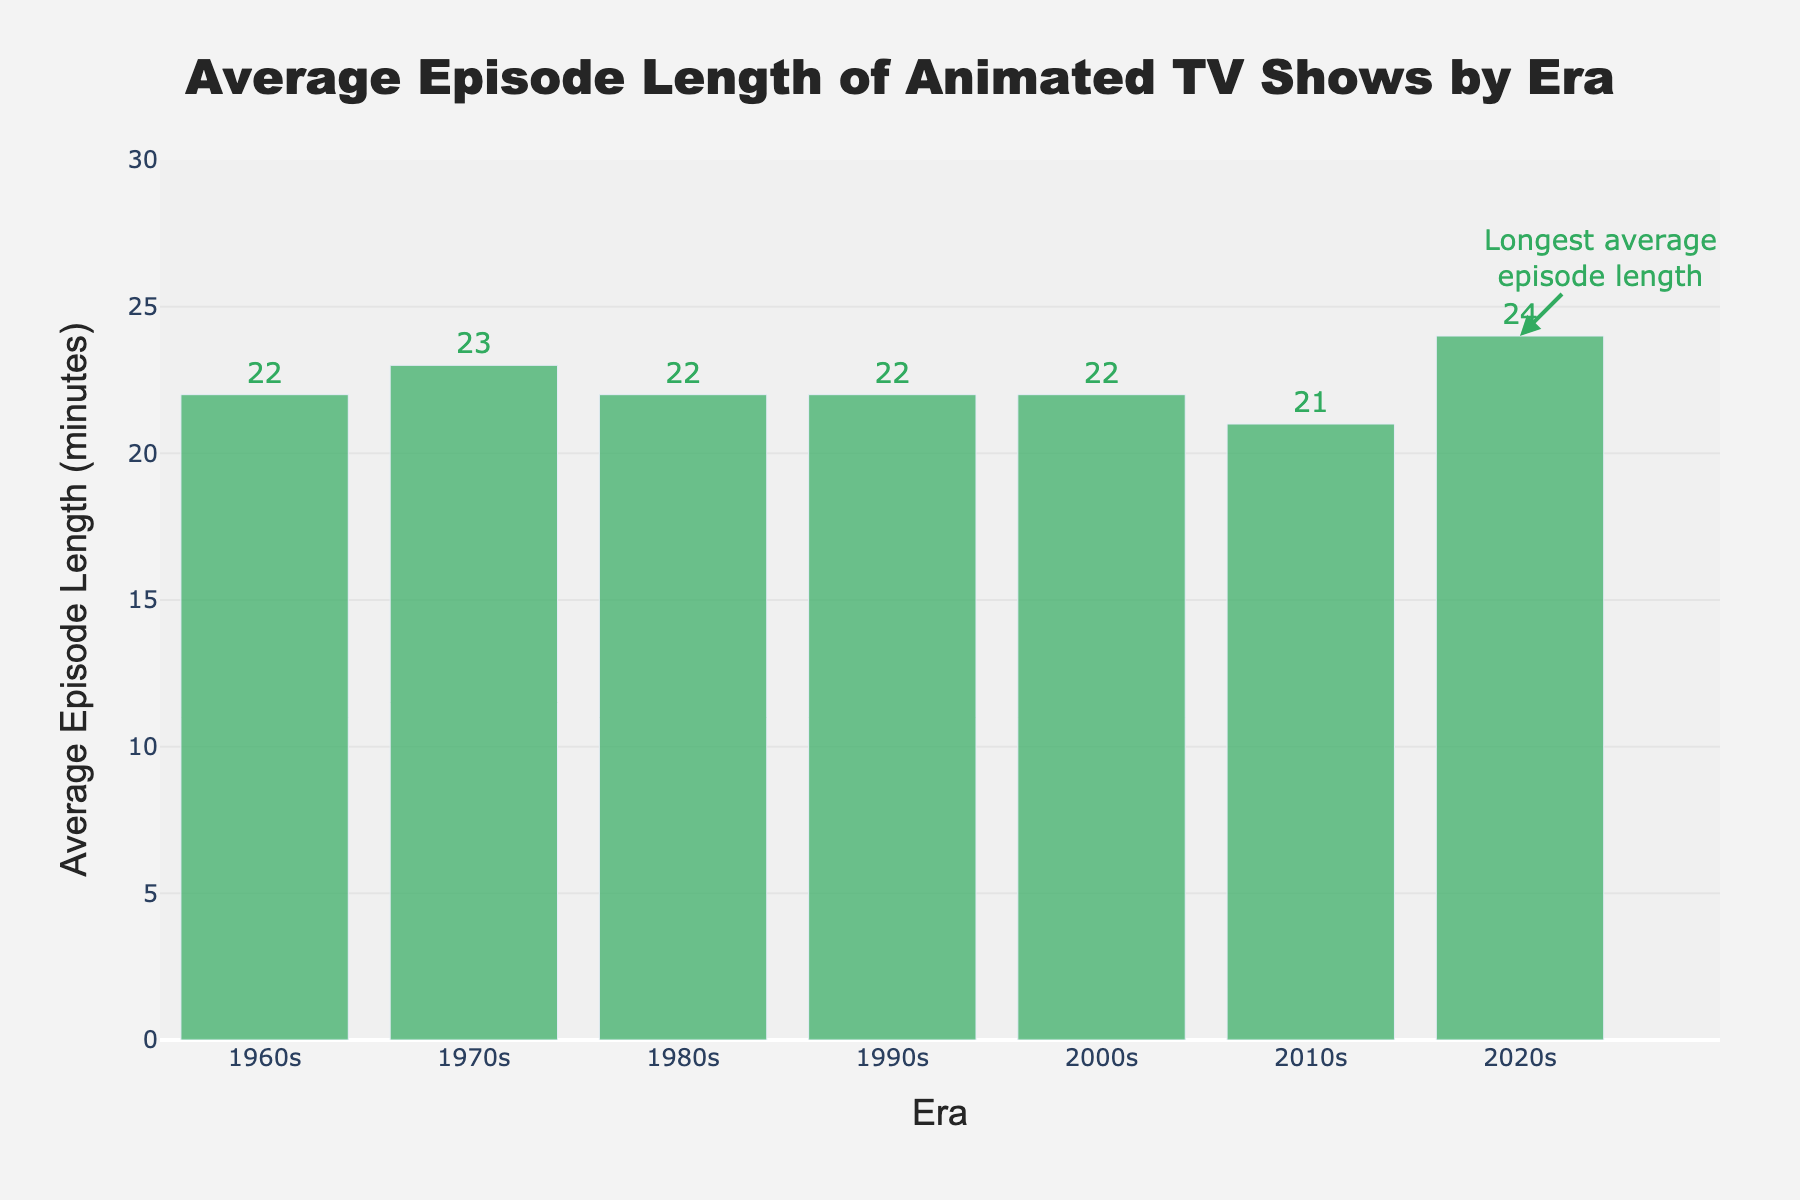What is the average episode length in the 2000s? The bar representing the 2000s shows an average episode length of 22 minutes.
Answer: 22 minutes Which era has the longest average episode length? The bar for the 2020s is the highest among all the bars, indicating the longest average episode length of 24 minutes.
Answer: 2020s By how much did the average episode length increase from the 2010s to the 2020s? The average episode length in the 2010s is 21 minutes, and in the 2020s it is 24 minutes. The difference is 24 - 21 = 3 minutes.
Answer: 3 minutes Compare the average episode lengths between the 1970s and the 2020s. Which one is longer and by how much? The 1970s have an average episode length of 23 minutes, while the 2020s have an average of 24 minutes. The 2020s are longer by 24 - 23 = 1 minute.
Answer: 2020s by 1 minute What is the trend in episode length from the 2010s to the 2020s? The average episode length has increased from 21 minutes in the 2010s to 24 minutes in the 2020s.
Answer: Increasing Is there any era where the average episode length is less than 22 minutes? Yes, the 2010s era has an average episode length of 21 minutes, which is less than 22 minutes.
Answer: 2010s What is the average episode length of animated TV shows in the 1990s and 2000s combined? Both the 1990s and 2000s have an average episode length of 22 minutes. Thus, the combined average remains 22 minutes.
Answer: 22 minutes How many eras have an average episode length of 22 minutes? The 1960s, 1980s, 1990s, and 2000s each have an average episode length of 22 minutes, making it four eras.
Answer: 4 eras Which era has the shortest average episode length, and what is it? The 2010s have the shortest average episode length, which is 21 minutes.
Answer: 2010s, 21 minutes Is the average episode length in the 1970s greater than in the 1960s? Yes, the average episode length in the 1970s is 23 minutes, which is greater than the average of 22 minutes in the 1960s by 1 minute.
Answer: Yes, by 1 minute 